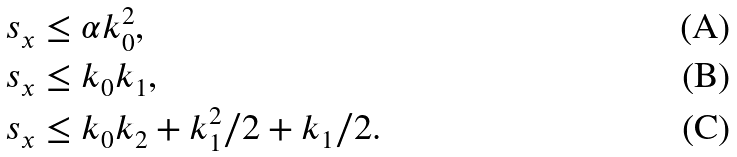Convert formula to latex. <formula><loc_0><loc_0><loc_500><loc_500>s _ { x } & \leq \alpha k _ { 0 } ^ { 2 } , \\ s _ { x } & \leq k _ { 0 } k _ { 1 } , \\ s _ { x } & \leq k _ { 0 } k _ { 2 } + k _ { 1 } ^ { 2 } / 2 + k _ { 1 } / 2 .</formula> 